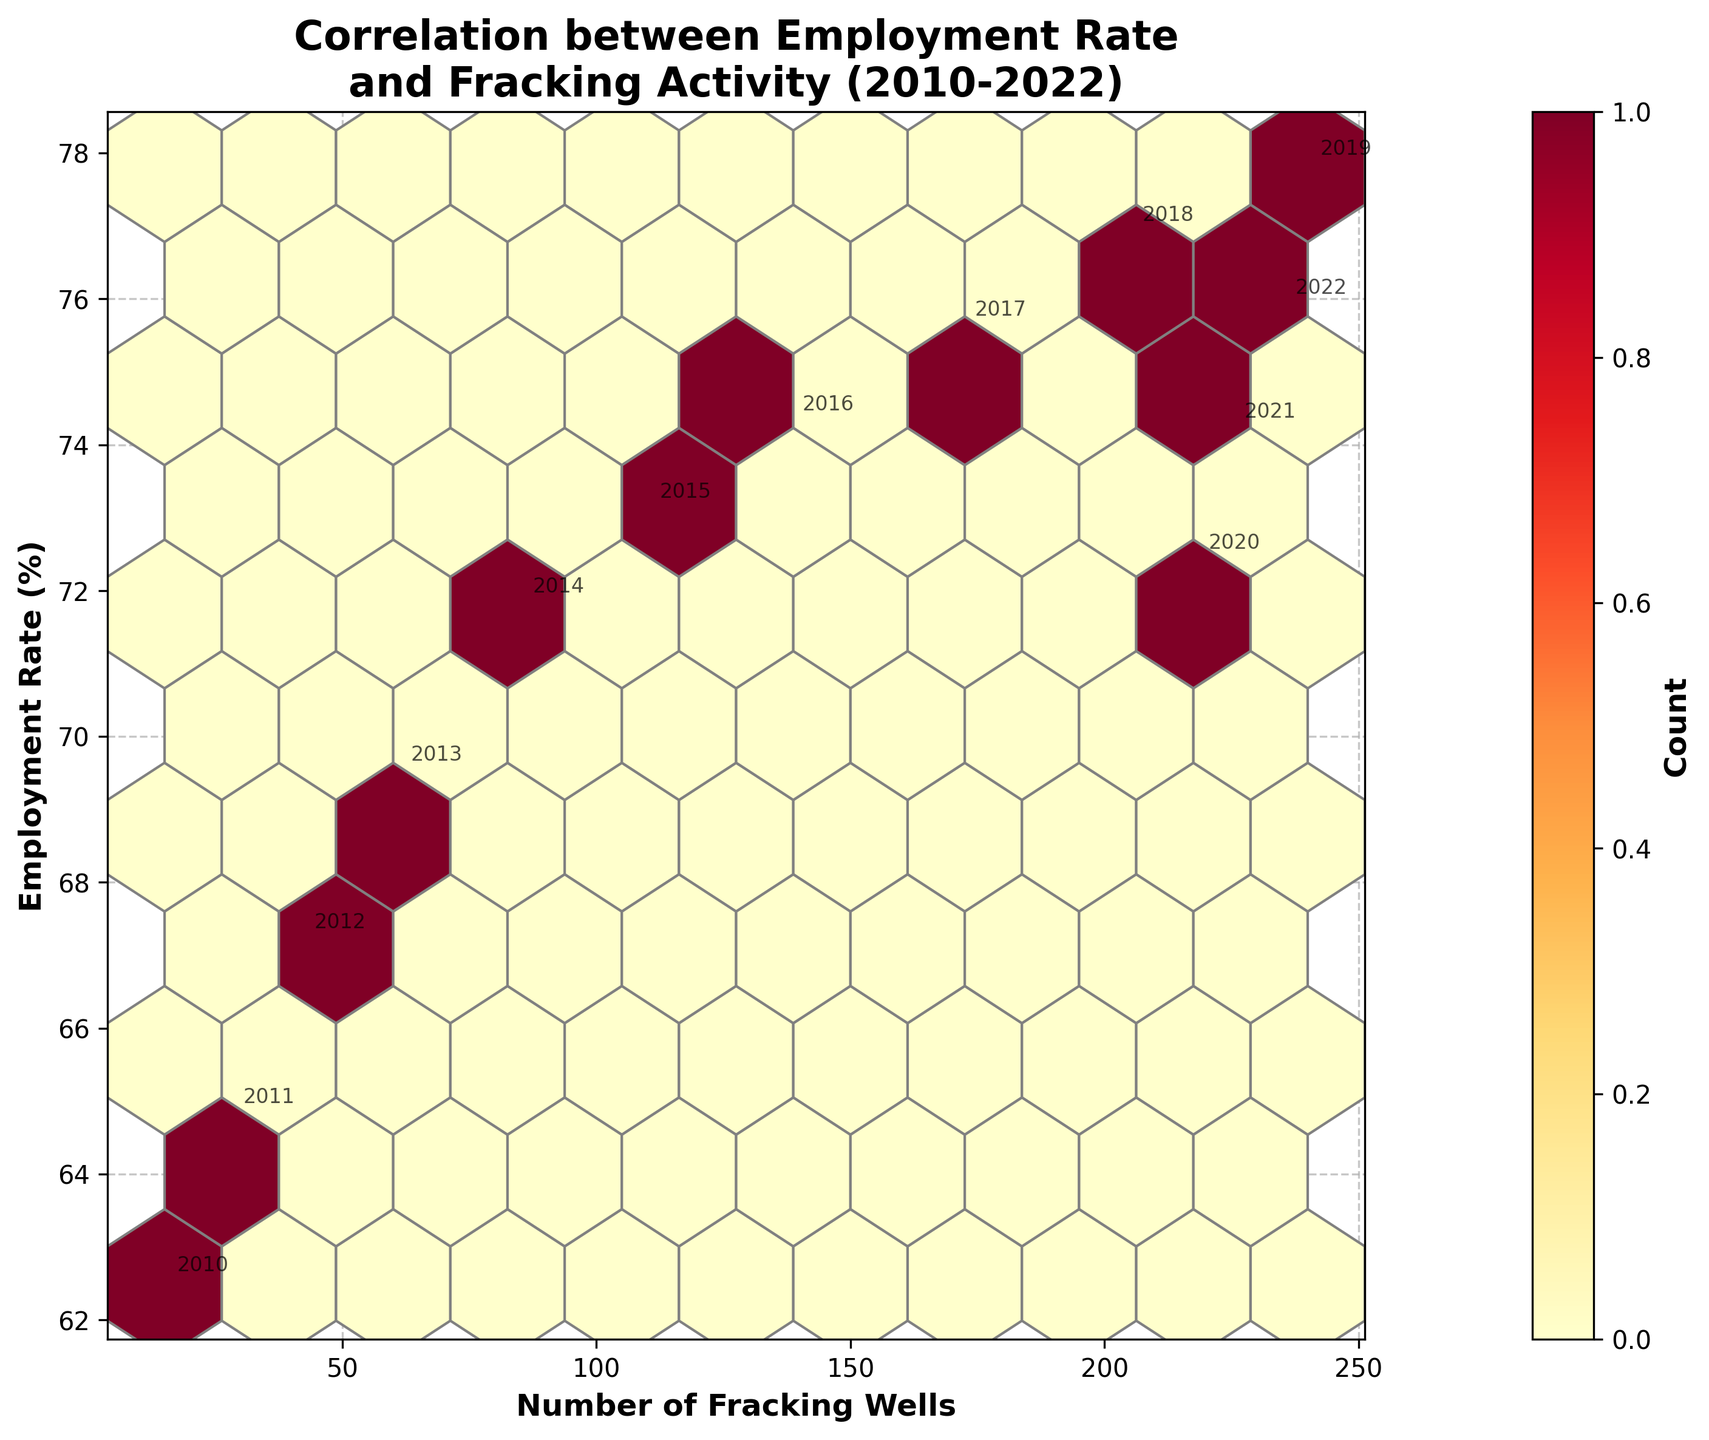What is the title of the hexbin plot? The title of the hexbin plot can be found at the top and reads, "Correlation between Employment Rate and Fracking Activity (2010-2022)"
Answer: Correlation between Employment Rate and Fracking Activity (2010-2022) How many data points are represented in the plot? The data points correspond to the number of rows in the data provided. In this case, each year is a data point, from 2010 to 2022.
Answer: 13 What is the range of the number of fracking wells in the hexbin plot? The lowest value for fracking wells appears to be 15, and the highest value is 240. This range is evident from the X-axis.
Answer: 15 to 240 Can you identify the year where employment rate declined and fracking wells decreased? Observing the annotations, there is a noticeable decline in 2020 where the employment rate decreased, and the number of fracking wells also slightly decreased.
Answer: 2020 What is the general trend of employment rate based on fracking activity according to the hexbin plot? By interpreting the trend in the hexbin plot, as the number of fracking wells increases, the employment rate appears to generally increase over the years, until a drop in 2020.
Answer: Increases Which year has the highest employment rate in the hexbin plot? The highest employment rate can be identified by the annotation and the Y-axis values, which is 2019.
Answer: 2019 In which hexbin cell is the highest concentration of data points located? The highest concentration is indicated by the darkest color on the plot, which represents the highest count of overlapping data points. This occurs around the region where fracking wells are between 60 and 210, and the employment rate ranges roughly between 75% and 77%.
Answer: Between 60 and 210 fracking wells and 75% to 77% employment rate How has the employment rate changed from 2010 to 2022? By noting the visual annotations, the employment rate increases from 62.5% in 2010 to 75.9% in 2022 with a notable drop in 2020.
Answer: Increased with a drop in 2020 Is there a strong correlation between fracking wells and employment rate, and how can you tell? A strong correlation can be identified through a noticeable trend in the plot; if the majority of hexbin cells trend diagonally and the density displays this relationship well, suggesting a positive correlation.
Answer: Yes, strong positive correlation 